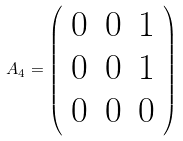Convert formula to latex. <formula><loc_0><loc_0><loc_500><loc_500>A _ { 4 } = \left ( \begin{array} { c c c } 0 & 0 & 1 \\ 0 & 0 & 1 \\ 0 & 0 & 0 \\ \end{array} \right )</formula> 